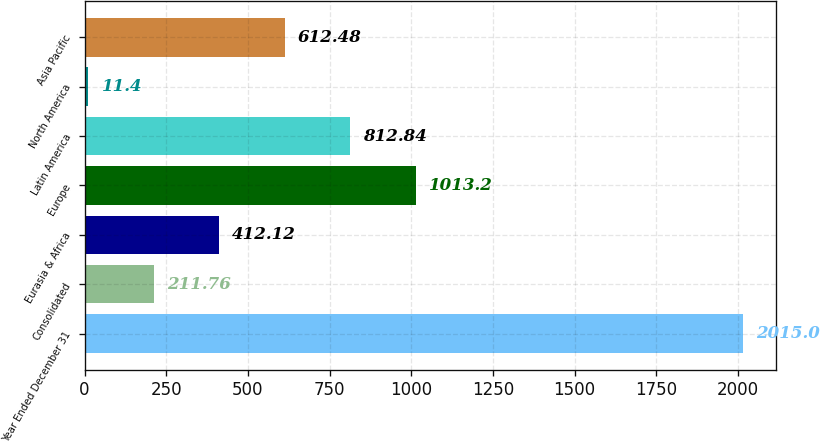Convert chart. <chart><loc_0><loc_0><loc_500><loc_500><bar_chart><fcel>Year Ended December 31<fcel>Consolidated<fcel>Eurasia & Africa<fcel>Europe<fcel>Latin America<fcel>North America<fcel>Asia Pacific<nl><fcel>2015<fcel>211.76<fcel>412.12<fcel>1013.2<fcel>812.84<fcel>11.4<fcel>612.48<nl></chart> 